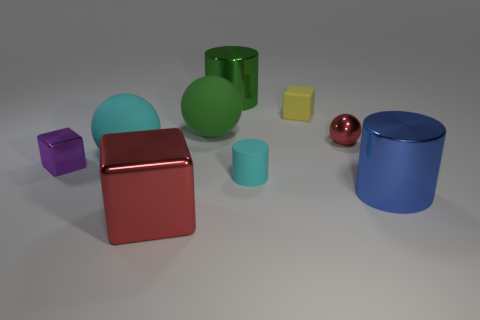There is a tiny yellow thing; what number of big red metal blocks are in front of it?
Keep it short and to the point. 1. How many green objects are either large spheres or big shiny spheres?
Offer a terse response. 1. There is a purple thing that is the same size as the cyan cylinder; what is its material?
Your response must be concise. Metal. What is the shape of the big thing that is on the right side of the large green matte ball and in front of the big green cylinder?
Provide a succinct answer. Cylinder. There is another rubber object that is the same size as the green rubber object; what is its color?
Keep it short and to the point. Cyan. There is a red shiny thing left of the tiny cyan matte thing; is it the same size as the metal cylinder behind the tiny yellow matte block?
Offer a very short reply. Yes. What is the size of the red shiny object that is behind the large metallic object in front of the large metallic cylinder in front of the yellow matte cube?
Give a very brief answer. Small. There is a big metallic object in front of the big thing to the right of the yellow rubber cube; what shape is it?
Ensure brevity in your answer.  Cube. Does the metallic cylinder that is to the left of the blue metallic cylinder have the same color as the large cube?
Your answer should be compact. No. What color is the tiny object that is in front of the small red metallic object and to the right of the green metallic cylinder?
Provide a short and direct response. Cyan. 